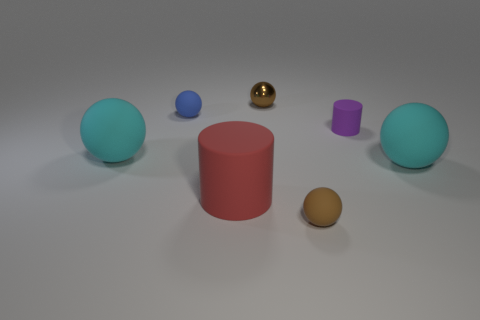Subtract all blue balls. How many balls are left? 4 Subtract all tiny brown matte balls. How many balls are left? 4 Add 2 small cyan spheres. How many objects exist? 9 Subtract all green spheres. Subtract all blue cylinders. How many spheres are left? 5 Subtract all balls. How many objects are left? 2 Add 4 blue rubber balls. How many blue rubber balls exist? 5 Subtract 0 blue cylinders. How many objects are left? 7 Subtract all large purple blocks. Subtract all small metallic spheres. How many objects are left? 6 Add 7 tiny brown rubber things. How many tiny brown rubber things are left? 8 